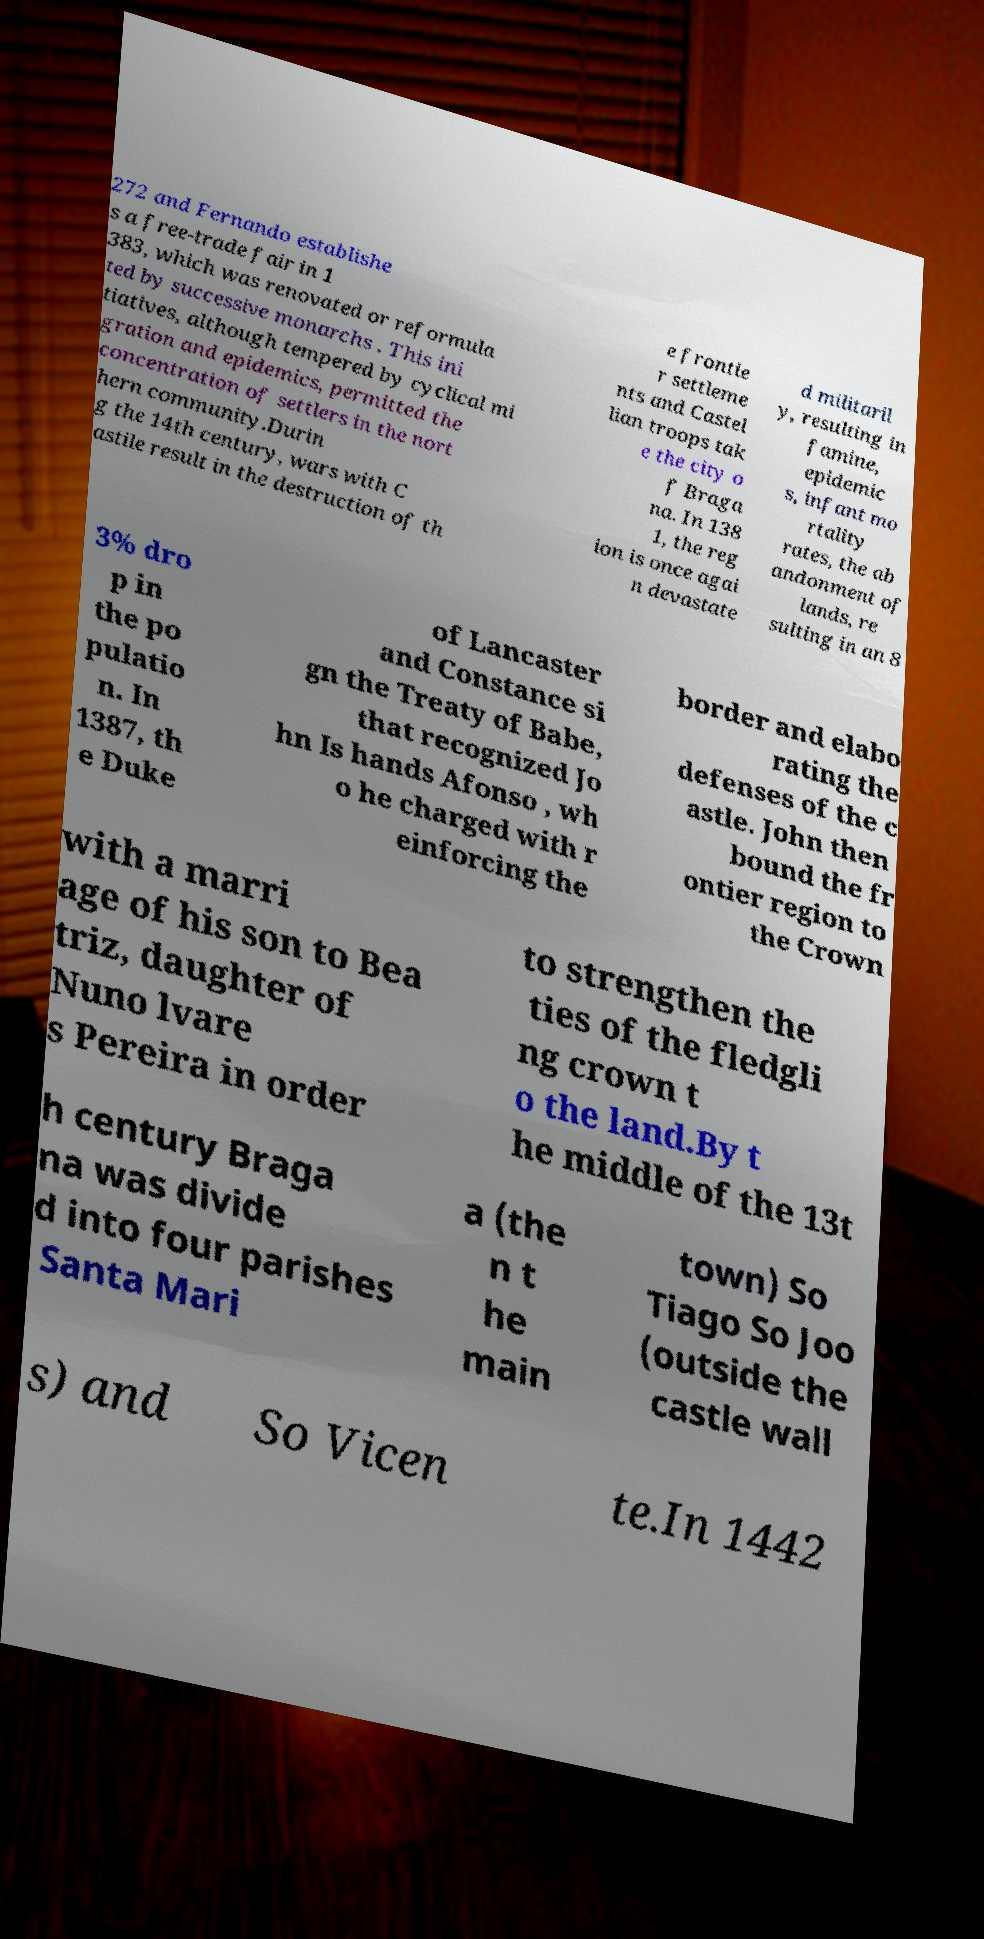There's text embedded in this image that I need extracted. Can you transcribe it verbatim? 272 and Fernando establishe s a free-trade fair in 1 383, which was renovated or reformula ted by successive monarchs . This ini tiatives, although tempered by cyclical mi gration and epidemics, permitted the concentration of settlers in the nort hern community.Durin g the 14th century, wars with C astile result in the destruction of th e frontie r settleme nts and Castel lian troops tak e the city o f Braga na. In 138 1, the reg ion is once agai n devastate d militaril y, resulting in famine, epidemic s, infant mo rtality rates, the ab andonment of lands, re sulting in an 8 3% dro p in the po pulatio n. In 1387, th e Duke of Lancaster and Constance si gn the Treaty of Babe, that recognized Jo hn Is hands Afonso , wh o he charged with r einforcing the border and elabo rating the defenses of the c astle. John then bound the fr ontier region to the Crown with a marri age of his son to Bea triz, daughter of Nuno lvare s Pereira in order to strengthen the ties of the fledgli ng crown t o the land.By t he middle of the 13t h century Braga na was divide d into four parishes Santa Mari a (the n t he main town) So Tiago So Joo (outside the castle wall s) and So Vicen te.In 1442 